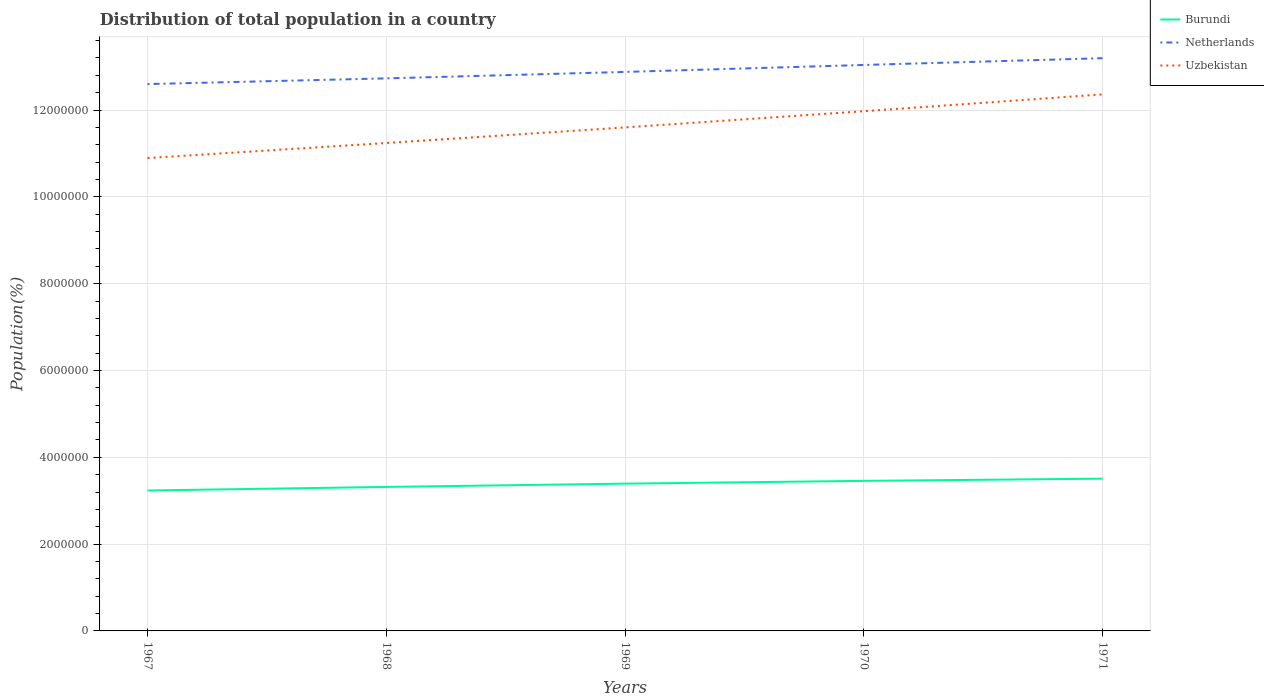How many different coloured lines are there?
Give a very brief answer. 3. Across all years, what is the maximum population of in Netherlands?
Ensure brevity in your answer.  1.26e+07. In which year was the population of in Burundi maximum?
Keep it short and to the point. 1967. What is the total population of in Netherlands in the graph?
Make the answer very short. -4.65e+05. What is the difference between the highest and the second highest population of in Netherlands?
Provide a short and direct response. 5.96e+05. Is the population of in Netherlands strictly greater than the population of in Uzbekistan over the years?
Keep it short and to the point. No. How many lines are there?
Your response must be concise. 3. What is the difference between two consecutive major ticks on the Y-axis?
Provide a short and direct response. 2.00e+06. How are the legend labels stacked?
Provide a short and direct response. Vertical. What is the title of the graph?
Offer a very short reply. Distribution of total population in a country. What is the label or title of the Y-axis?
Make the answer very short. Population(%). What is the Population(%) of Burundi in 1967?
Give a very brief answer. 3.24e+06. What is the Population(%) in Netherlands in 1967?
Offer a very short reply. 1.26e+07. What is the Population(%) of Uzbekistan in 1967?
Offer a very short reply. 1.09e+07. What is the Population(%) in Burundi in 1968?
Give a very brief answer. 3.32e+06. What is the Population(%) in Netherlands in 1968?
Your response must be concise. 1.27e+07. What is the Population(%) of Uzbekistan in 1968?
Make the answer very short. 1.12e+07. What is the Population(%) of Burundi in 1969?
Your response must be concise. 3.39e+06. What is the Population(%) in Netherlands in 1969?
Your answer should be compact. 1.29e+07. What is the Population(%) in Uzbekistan in 1969?
Provide a succinct answer. 1.16e+07. What is the Population(%) of Burundi in 1970?
Offer a terse response. 3.46e+06. What is the Population(%) in Netherlands in 1970?
Keep it short and to the point. 1.30e+07. What is the Population(%) in Uzbekistan in 1970?
Your answer should be compact. 1.20e+07. What is the Population(%) in Burundi in 1971?
Your response must be concise. 3.51e+06. What is the Population(%) in Netherlands in 1971?
Your response must be concise. 1.32e+07. What is the Population(%) of Uzbekistan in 1971?
Provide a short and direct response. 1.24e+07. Across all years, what is the maximum Population(%) of Burundi?
Give a very brief answer. 3.51e+06. Across all years, what is the maximum Population(%) of Netherlands?
Provide a short and direct response. 1.32e+07. Across all years, what is the maximum Population(%) in Uzbekistan?
Make the answer very short. 1.24e+07. Across all years, what is the minimum Population(%) of Burundi?
Make the answer very short. 3.24e+06. Across all years, what is the minimum Population(%) of Netherlands?
Provide a short and direct response. 1.26e+07. Across all years, what is the minimum Population(%) of Uzbekistan?
Offer a very short reply. 1.09e+07. What is the total Population(%) of Burundi in the graph?
Provide a short and direct response. 1.69e+07. What is the total Population(%) of Netherlands in the graph?
Provide a short and direct response. 6.44e+07. What is the total Population(%) of Uzbekistan in the graph?
Your answer should be very brief. 5.81e+07. What is the difference between the Population(%) in Burundi in 1967 and that in 1968?
Ensure brevity in your answer.  -8.22e+04. What is the difference between the Population(%) in Netherlands in 1967 and that in 1968?
Give a very brief answer. -1.32e+05. What is the difference between the Population(%) of Uzbekistan in 1967 and that in 1968?
Your response must be concise. -3.46e+05. What is the difference between the Population(%) of Burundi in 1967 and that in 1969?
Your response must be concise. -1.58e+05. What is the difference between the Population(%) of Netherlands in 1967 and that in 1969?
Offer a terse response. -2.80e+05. What is the difference between the Population(%) of Uzbekistan in 1967 and that in 1969?
Give a very brief answer. -7.05e+05. What is the difference between the Population(%) of Burundi in 1967 and that in 1970?
Keep it short and to the point. -2.22e+05. What is the difference between the Population(%) in Netherlands in 1967 and that in 1970?
Your answer should be compact. -4.40e+05. What is the difference between the Population(%) in Uzbekistan in 1967 and that in 1970?
Offer a very short reply. -1.08e+06. What is the difference between the Population(%) in Burundi in 1967 and that in 1971?
Offer a very short reply. -2.72e+05. What is the difference between the Population(%) in Netherlands in 1967 and that in 1971?
Your answer should be very brief. -5.96e+05. What is the difference between the Population(%) of Uzbekistan in 1967 and that in 1971?
Offer a terse response. -1.47e+06. What is the difference between the Population(%) of Burundi in 1968 and that in 1969?
Provide a short and direct response. -7.56e+04. What is the difference between the Population(%) of Netherlands in 1968 and that in 1969?
Make the answer very short. -1.48e+05. What is the difference between the Population(%) in Uzbekistan in 1968 and that in 1969?
Your response must be concise. -3.59e+05. What is the difference between the Population(%) in Burundi in 1968 and that in 1970?
Ensure brevity in your answer.  -1.40e+05. What is the difference between the Population(%) of Netherlands in 1968 and that in 1970?
Provide a short and direct response. -3.09e+05. What is the difference between the Population(%) in Uzbekistan in 1968 and that in 1970?
Your answer should be compact. -7.32e+05. What is the difference between the Population(%) of Burundi in 1968 and that in 1971?
Provide a succinct answer. -1.90e+05. What is the difference between the Population(%) in Netherlands in 1968 and that in 1971?
Make the answer very short. -4.65e+05. What is the difference between the Population(%) of Uzbekistan in 1968 and that in 1971?
Make the answer very short. -1.12e+06. What is the difference between the Population(%) of Burundi in 1969 and that in 1970?
Ensure brevity in your answer.  -6.42e+04. What is the difference between the Population(%) of Netherlands in 1969 and that in 1970?
Your answer should be very brief. -1.61e+05. What is the difference between the Population(%) of Uzbekistan in 1969 and that in 1970?
Ensure brevity in your answer.  -3.73e+05. What is the difference between the Population(%) of Burundi in 1969 and that in 1971?
Ensure brevity in your answer.  -1.15e+05. What is the difference between the Population(%) of Netherlands in 1969 and that in 1971?
Your answer should be compact. -3.17e+05. What is the difference between the Population(%) of Uzbekistan in 1969 and that in 1971?
Offer a very short reply. -7.61e+05. What is the difference between the Population(%) in Burundi in 1970 and that in 1971?
Your answer should be compact. -5.05e+04. What is the difference between the Population(%) of Netherlands in 1970 and that in 1971?
Give a very brief answer. -1.56e+05. What is the difference between the Population(%) of Uzbekistan in 1970 and that in 1971?
Offer a very short reply. -3.88e+05. What is the difference between the Population(%) in Burundi in 1967 and the Population(%) in Netherlands in 1968?
Your response must be concise. -9.49e+06. What is the difference between the Population(%) of Burundi in 1967 and the Population(%) of Uzbekistan in 1968?
Your response must be concise. -8.01e+06. What is the difference between the Population(%) of Netherlands in 1967 and the Population(%) of Uzbekistan in 1968?
Your answer should be very brief. 1.36e+06. What is the difference between the Population(%) of Burundi in 1967 and the Population(%) of Netherlands in 1969?
Provide a succinct answer. -9.64e+06. What is the difference between the Population(%) of Burundi in 1967 and the Population(%) of Uzbekistan in 1969?
Your answer should be compact. -8.36e+06. What is the difference between the Population(%) in Netherlands in 1967 and the Population(%) in Uzbekistan in 1969?
Offer a very short reply. 9.98e+05. What is the difference between the Population(%) in Burundi in 1967 and the Population(%) in Netherlands in 1970?
Keep it short and to the point. -9.80e+06. What is the difference between the Population(%) of Burundi in 1967 and the Population(%) of Uzbekistan in 1970?
Give a very brief answer. -8.74e+06. What is the difference between the Population(%) of Netherlands in 1967 and the Population(%) of Uzbekistan in 1970?
Your answer should be compact. 6.25e+05. What is the difference between the Population(%) of Burundi in 1967 and the Population(%) of Netherlands in 1971?
Your response must be concise. -9.96e+06. What is the difference between the Population(%) of Burundi in 1967 and the Population(%) of Uzbekistan in 1971?
Make the answer very short. -9.13e+06. What is the difference between the Population(%) in Netherlands in 1967 and the Population(%) in Uzbekistan in 1971?
Provide a short and direct response. 2.37e+05. What is the difference between the Population(%) in Burundi in 1968 and the Population(%) in Netherlands in 1969?
Make the answer very short. -9.56e+06. What is the difference between the Population(%) of Burundi in 1968 and the Population(%) of Uzbekistan in 1969?
Your answer should be compact. -8.28e+06. What is the difference between the Population(%) of Netherlands in 1968 and the Population(%) of Uzbekistan in 1969?
Make the answer very short. 1.13e+06. What is the difference between the Population(%) of Burundi in 1968 and the Population(%) of Netherlands in 1970?
Offer a terse response. -9.72e+06. What is the difference between the Population(%) of Burundi in 1968 and the Population(%) of Uzbekistan in 1970?
Keep it short and to the point. -8.66e+06. What is the difference between the Population(%) of Netherlands in 1968 and the Population(%) of Uzbekistan in 1970?
Provide a succinct answer. 7.57e+05. What is the difference between the Population(%) of Burundi in 1968 and the Population(%) of Netherlands in 1971?
Offer a very short reply. -9.88e+06. What is the difference between the Population(%) in Burundi in 1968 and the Population(%) in Uzbekistan in 1971?
Offer a very short reply. -9.04e+06. What is the difference between the Population(%) in Netherlands in 1968 and the Population(%) in Uzbekistan in 1971?
Your response must be concise. 3.68e+05. What is the difference between the Population(%) in Burundi in 1969 and the Population(%) in Netherlands in 1970?
Ensure brevity in your answer.  -9.65e+06. What is the difference between the Population(%) in Burundi in 1969 and the Population(%) in Uzbekistan in 1970?
Offer a very short reply. -8.58e+06. What is the difference between the Population(%) of Netherlands in 1969 and the Population(%) of Uzbekistan in 1970?
Your answer should be compact. 9.05e+05. What is the difference between the Population(%) in Burundi in 1969 and the Population(%) in Netherlands in 1971?
Offer a terse response. -9.80e+06. What is the difference between the Population(%) in Burundi in 1969 and the Population(%) in Uzbekistan in 1971?
Give a very brief answer. -8.97e+06. What is the difference between the Population(%) in Netherlands in 1969 and the Population(%) in Uzbekistan in 1971?
Keep it short and to the point. 5.17e+05. What is the difference between the Population(%) in Burundi in 1970 and the Population(%) in Netherlands in 1971?
Provide a short and direct response. -9.74e+06. What is the difference between the Population(%) in Burundi in 1970 and the Population(%) in Uzbekistan in 1971?
Offer a very short reply. -8.90e+06. What is the difference between the Population(%) of Netherlands in 1970 and the Population(%) of Uzbekistan in 1971?
Provide a short and direct response. 6.77e+05. What is the average Population(%) in Burundi per year?
Offer a very short reply. 3.38e+06. What is the average Population(%) of Netherlands per year?
Offer a terse response. 1.29e+07. What is the average Population(%) of Uzbekistan per year?
Provide a short and direct response. 1.16e+07. In the year 1967, what is the difference between the Population(%) of Burundi and Population(%) of Netherlands?
Offer a terse response. -9.36e+06. In the year 1967, what is the difference between the Population(%) of Burundi and Population(%) of Uzbekistan?
Provide a succinct answer. -7.66e+06. In the year 1967, what is the difference between the Population(%) in Netherlands and Population(%) in Uzbekistan?
Your answer should be very brief. 1.70e+06. In the year 1968, what is the difference between the Population(%) in Burundi and Population(%) in Netherlands?
Your response must be concise. -9.41e+06. In the year 1968, what is the difference between the Population(%) in Burundi and Population(%) in Uzbekistan?
Your answer should be compact. -7.92e+06. In the year 1968, what is the difference between the Population(%) of Netherlands and Population(%) of Uzbekistan?
Keep it short and to the point. 1.49e+06. In the year 1969, what is the difference between the Population(%) of Burundi and Population(%) of Netherlands?
Your answer should be very brief. -9.49e+06. In the year 1969, what is the difference between the Population(%) of Burundi and Population(%) of Uzbekistan?
Provide a short and direct response. -8.21e+06. In the year 1969, what is the difference between the Population(%) of Netherlands and Population(%) of Uzbekistan?
Your answer should be compact. 1.28e+06. In the year 1970, what is the difference between the Population(%) in Burundi and Population(%) in Netherlands?
Offer a terse response. -9.58e+06. In the year 1970, what is the difference between the Population(%) of Burundi and Population(%) of Uzbekistan?
Your response must be concise. -8.52e+06. In the year 1970, what is the difference between the Population(%) of Netherlands and Population(%) of Uzbekistan?
Make the answer very short. 1.07e+06. In the year 1971, what is the difference between the Population(%) in Burundi and Population(%) in Netherlands?
Your answer should be very brief. -9.69e+06. In the year 1971, what is the difference between the Population(%) in Burundi and Population(%) in Uzbekistan?
Offer a very short reply. -8.85e+06. In the year 1971, what is the difference between the Population(%) of Netherlands and Population(%) of Uzbekistan?
Your response must be concise. 8.33e+05. What is the ratio of the Population(%) of Burundi in 1967 to that in 1968?
Keep it short and to the point. 0.98. What is the ratio of the Population(%) in Uzbekistan in 1967 to that in 1968?
Offer a terse response. 0.97. What is the ratio of the Population(%) in Burundi in 1967 to that in 1969?
Make the answer very short. 0.95. What is the ratio of the Population(%) of Netherlands in 1967 to that in 1969?
Ensure brevity in your answer.  0.98. What is the ratio of the Population(%) in Uzbekistan in 1967 to that in 1969?
Your response must be concise. 0.94. What is the ratio of the Population(%) of Burundi in 1967 to that in 1970?
Keep it short and to the point. 0.94. What is the ratio of the Population(%) in Netherlands in 1967 to that in 1970?
Your response must be concise. 0.97. What is the ratio of the Population(%) in Uzbekistan in 1967 to that in 1970?
Provide a succinct answer. 0.91. What is the ratio of the Population(%) of Burundi in 1967 to that in 1971?
Keep it short and to the point. 0.92. What is the ratio of the Population(%) in Netherlands in 1967 to that in 1971?
Provide a succinct answer. 0.95. What is the ratio of the Population(%) of Uzbekistan in 1967 to that in 1971?
Your response must be concise. 0.88. What is the ratio of the Population(%) of Burundi in 1968 to that in 1969?
Provide a succinct answer. 0.98. What is the ratio of the Population(%) of Netherlands in 1968 to that in 1969?
Give a very brief answer. 0.99. What is the ratio of the Population(%) in Uzbekistan in 1968 to that in 1969?
Offer a very short reply. 0.97. What is the ratio of the Population(%) in Burundi in 1968 to that in 1970?
Ensure brevity in your answer.  0.96. What is the ratio of the Population(%) in Netherlands in 1968 to that in 1970?
Offer a terse response. 0.98. What is the ratio of the Population(%) in Uzbekistan in 1968 to that in 1970?
Ensure brevity in your answer.  0.94. What is the ratio of the Population(%) of Burundi in 1968 to that in 1971?
Provide a succinct answer. 0.95. What is the ratio of the Population(%) in Netherlands in 1968 to that in 1971?
Your answer should be compact. 0.96. What is the ratio of the Population(%) in Uzbekistan in 1968 to that in 1971?
Ensure brevity in your answer.  0.91. What is the ratio of the Population(%) in Burundi in 1969 to that in 1970?
Keep it short and to the point. 0.98. What is the ratio of the Population(%) of Netherlands in 1969 to that in 1970?
Give a very brief answer. 0.99. What is the ratio of the Population(%) of Uzbekistan in 1969 to that in 1970?
Offer a terse response. 0.97. What is the ratio of the Population(%) of Burundi in 1969 to that in 1971?
Give a very brief answer. 0.97. What is the ratio of the Population(%) in Netherlands in 1969 to that in 1971?
Your answer should be compact. 0.98. What is the ratio of the Population(%) of Uzbekistan in 1969 to that in 1971?
Keep it short and to the point. 0.94. What is the ratio of the Population(%) of Burundi in 1970 to that in 1971?
Your answer should be very brief. 0.99. What is the ratio of the Population(%) in Netherlands in 1970 to that in 1971?
Your response must be concise. 0.99. What is the ratio of the Population(%) in Uzbekistan in 1970 to that in 1971?
Keep it short and to the point. 0.97. What is the difference between the highest and the second highest Population(%) of Burundi?
Your answer should be very brief. 5.05e+04. What is the difference between the highest and the second highest Population(%) in Netherlands?
Provide a succinct answer. 1.56e+05. What is the difference between the highest and the second highest Population(%) in Uzbekistan?
Keep it short and to the point. 3.88e+05. What is the difference between the highest and the lowest Population(%) in Burundi?
Provide a short and direct response. 2.72e+05. What is the difference between the highest and the lowest Population(%) in Netherlands?
Offer a very short reply. 5.96e+05. What is the difference between the highest and the lowest Population(%) in Uzbekistan?
Offer a terse response. 1.47e+06. 